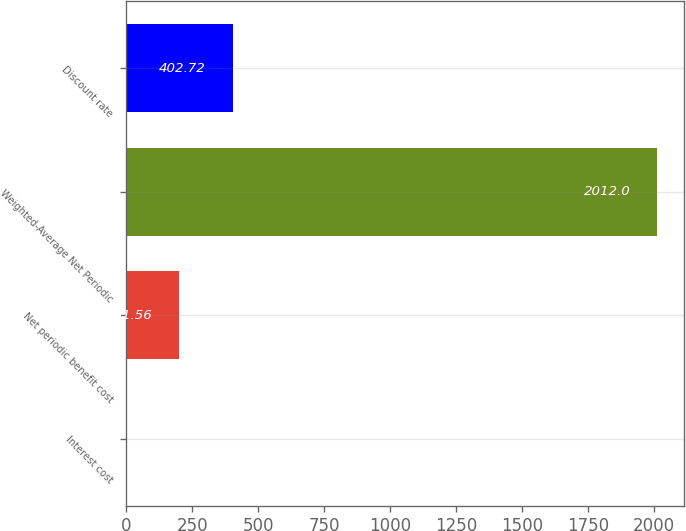Convert chart to OTSL. <chart><loc_0><loc_0><loc_500><loc_500><bar_chart><fcel>Interest cost<fcel>Net periodic benefit cost<fcel>Weighted-Average Net Periodic<fcel>Discount rate<nl><fcel>0.4<fcel>201.56<fcel>2012<fcel>402.72<nl></chart> 